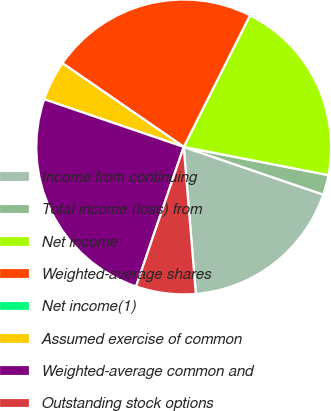<chart> <loc_0><loc_0><loc_500><loc_500><pie_chart><fcel>Income from continuing<fcel>Total income (loss) from<fcel>Net income<fcel>Weighted-average shares<fcel>Net income(1)<fcel>Assumed exercise of common<fcel>Weighted-average common and<fcel>Outstanding stock options<nl><fcel>18.45%<fcel>2.18%<fcel>20.63%<fcel>22.82%<fcel>0.0%<fcel>4.37%<fcel>25.0%<fcel>6.55%<nl></chart> 